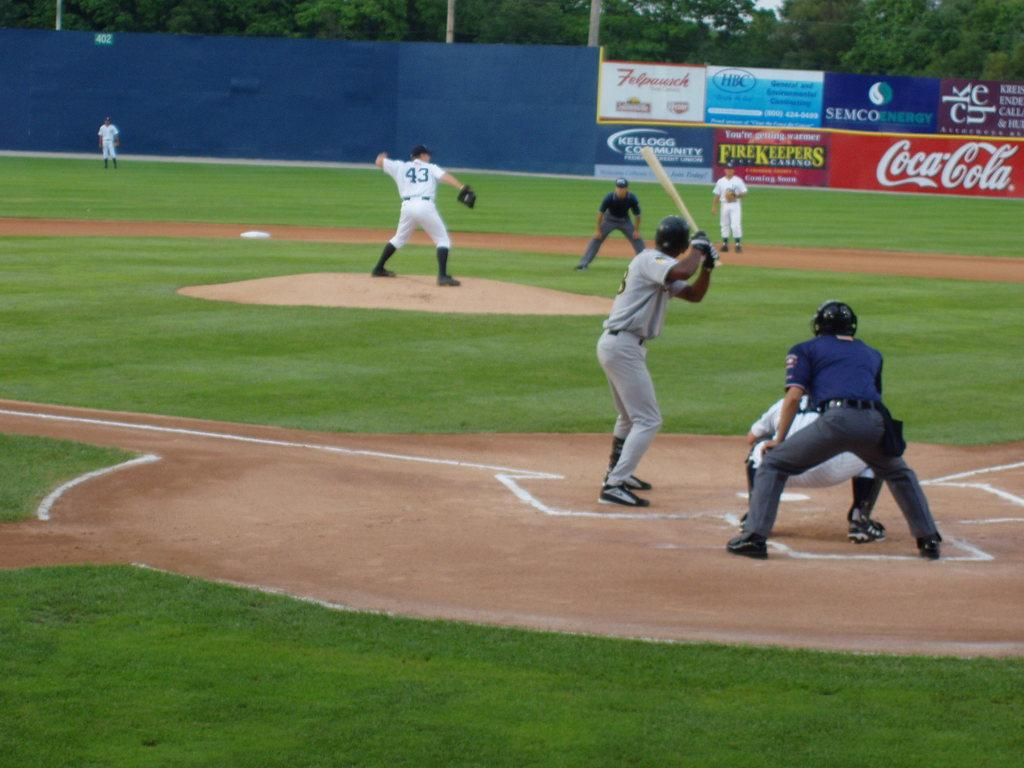<image>
Write a terse but informative summary of the picture. Man about to bat while number 43 is pitching the ball. 